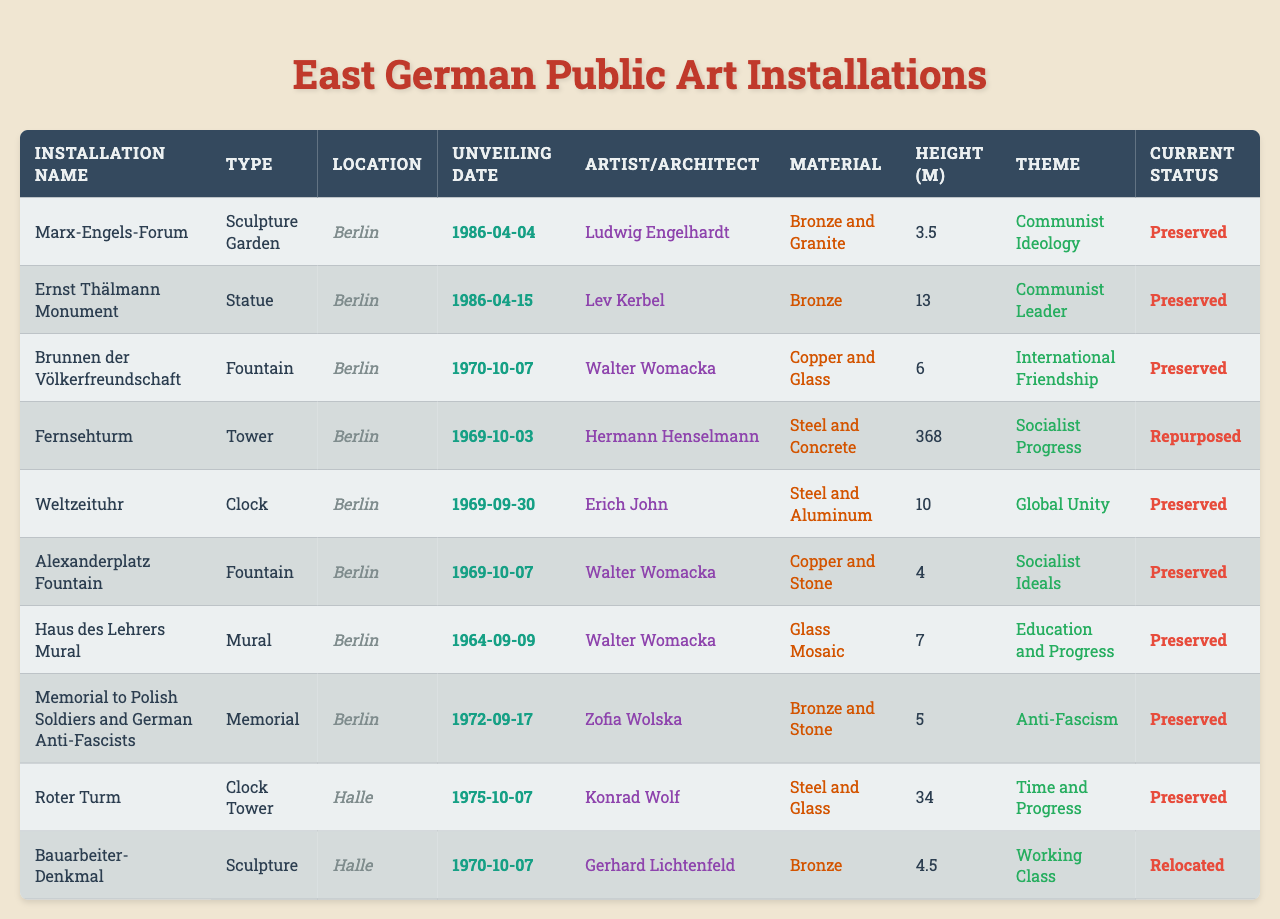What is the unveiling date of the Fernsehturm? The unveiling date is listed in the "Unveiling Date" column next to the "Fernsehturm" entry. It shows "1969-10-03."
Answer: 1969-10-03 How many art installations are located in Halle? By checking the "Location" column, we see that "Halle" is mentioned twice, indicating two installations.
Answer: 2 Who is the artist of the Haus des Lehrers Mural? The artist can be found in the "Artist/Architect" column next to "Haus des Lehrers Mural," which shows "Walter Womacka."
Answer: Walter Womacka What is the height of the Ernst Thälmann Monument? Referring to the "Height (meters)" column, we find that the height for "Ernst Thälmann Monument" is 13 meters.
Answer: 13 Is the Brunnen der Völkerfreundschaft preserved? The "Current Status" column indicates that the status next to "Brunnen der Völkerfreundschaft" is "Preserved," confirming that it is indeed preserved.
Answer: Yes What is the most common type of art installation in Berlin? By reviewing the "Type" column for installations in Berlin, we find that "Fountain" occurs twice, making it the most common type.
Answer: Fountain How tall is the tallest installation, and what is its name? The tallest installation is identified by comparing the heights listed. The "Fernsehturm" has a height of 368 meters, which is greater than all other installations.
Answer: Fernsehturm, 368 meters What themes are represented in the installations located in Halle? The installations in Halle—"Roter Turm" and "Bauarbeiter-Denkmal"—have themes of "Time and Progress" and "Working Class," respectively.
Answer: Time and Progress, Working Class When was the Haus des Lehrers Mural unveiled compared to the Weltzeituhr? The unveiling dates are "1964-09-09" for the "Haus des Lehrers Mural" and "1969-09-30" for the "Weltzeituhr." The Haus des Lehrers Mural was unveiled 5 years prior.
Answer: 5 years earlier Which installation uses copper as a material? Looking at the "Material" column, "Brunnen der Völkerfreundschaft" and "Alexanderplatz Fountain" both feature copper; thus, both installations utilize this material.
Answer: Brunnen der Völkerfreundschaft, Alexanderplatz Fountain Are there more installations with a height over 10 meters or below 10 meters? To answer, we need to count: heights over 10 meters are for "Fernsehturm" (368), "Weltzeituhr" (10), and "Roter Turm" (34), giving us 3. Heights below 10 meters come from the rest of the installations, totaling 7. There are fewer installations over 10 meters.
Answer: Below 10 meters has more installations 